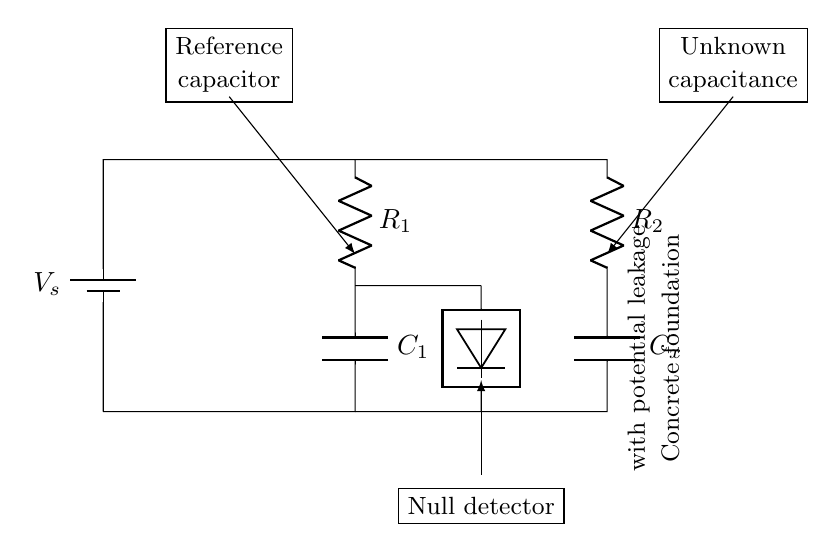What is the power source of this circuit? The circuit is powered by a battery, as indicated by the symbol for the battery labeled V_s. This shows that it provides the necessary voltage to the system.
Answer: battery What is the function of C1 in the circuit? C1 is the reference capacitor, which is used to establish a standard capacitance against which the unknown capacitance (Cx) can be compared. This aids in detecting variations in capacitance due to water leakage.
Answer: reference capacitor How many resistors are present in the circuit? There are two resistors in the circuit, R1 and R2, which help to balance the bridge and are critical for accurate capacitance measurement.
Answer: two What does the null detector measure? The null detector measures the difference in electrical potential (or null condition) between the two branches of the circuit, which indicates whether the capacitance is balanced or if there is a deviation due to leakage.
Answer: potential difference What type of circuit is depicted? The circuit depicted is a capacitance bridge, specifically designed for comparing an unknown capacitance (Cx) with a known reference capacitance (C1) to detect water leakage in concrete foundations.
Answer: capacitance bridge What is Cx in the circuit? Cx represents the unknown capacitance that is being tested or compared against the known capacitance (C1) to identify potential water leakage in the foundation.
Answer: unknown capacitance How is the concrete foundation relevant to this circuit? The concrete foundation is significant as it is the target area for assessing moisture content; a change in capacitance detected by the bridge indicates potential water leakage in the concrete.
Answer: moisture detection 